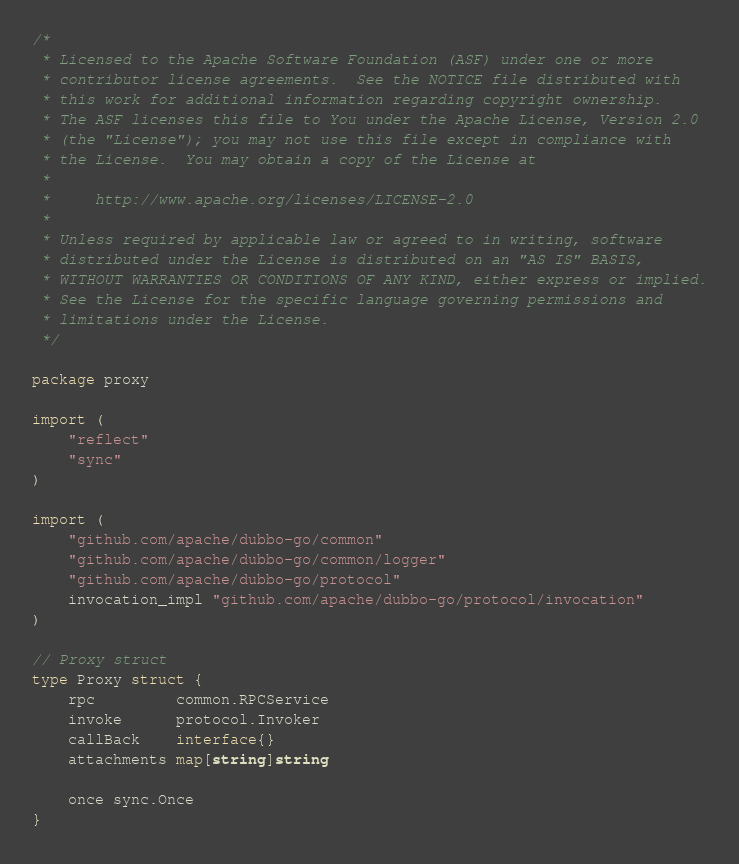Convert code to text. <code><loc_0><loc_0><loc_500><loc_500><_Go_>/*
 * Licensed to the Apache Software Foundation (ASF) under one or more
 * contributor license agreements.  See the NOTICE file distributed with
 * this work for additional information regarding copyright ownership.
 * The ASF licenses this file to You under the Apache License, Version 2.0
 * (the "License"); you may not use this file except in compliance with
 * the License.  You may obtain a copy of the License at
 *
 *     http://www.apache.org/licenses/LICENSE-2.0
 *
 * Unless required by applicable law or agreed to in writing, software
 * distributed under the License is distributed on an "AS IS" BASIS,
 * WITHOUT WARRANTIES OR CONDITIONS OF ANY KIND, either express or implied.
 * See the License for the specific language governing permissions and
 * limitations under the License.
 */

package proxy

import (
	"reflect"
	"sync"
)

import (
	"github.com/apache/dubbo-go/common"
	"github.com/apache/dubbo-go/common/logger"
	"github.com/apache/dubbo-go/protocol"
	invocation_impl "github.com/apache/dubbo-go/protocol/invocation"
)

// Proxy struct
type Proxy struct {
	rpc         common.RPCService
	invoke      protocol.Invoker
	callBack    interface{}
	attachments map[string]string

	once sync.Once
}
</code> 